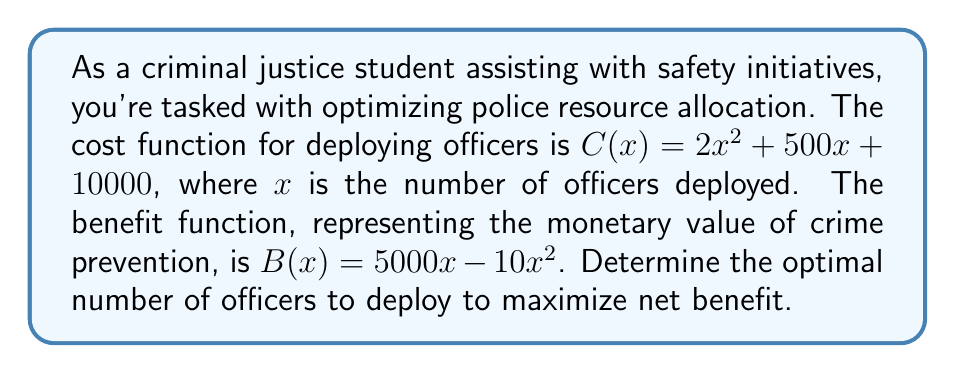Could you help me with this problem? 1) The net benefit function is the difference between benefit and cost:
   $N(x) = B(x) - C(x) = (5000x - 10x^2) - (2x^2 + 500x + 10000)$
   $N(x) = -12x^2 + 4500x - 10000$

2) To find the maximum net benefit, we need to find where the derivative of $N(x)$ equals zero:
   $\frac{dN}{dx} = -24x + 4500$

3) Set the derivative to zero and solve for $x$:
   $-24x + 4500 = 0$
   $-24x = -4500$
   $x = \frac{4500}{24} = 187.5$

4) To confirm this is a maximum, check the second derivative:
   $\frac{d^2N}{dx^2} = -24$, which is negative, confirming a maximum.

5) Since we can't deploy a fractional number of officers, we round to the nearest whole number: 188 officers.

6) Verify by checking net benefit for 187, 188, and 189 officers:
   $N(187) = -419,332$
   $N(188) = -419,328$
   $N(189) = -419,336$

   188 officers indeed provides the maximum net benefit.
Answer: 188 officers 